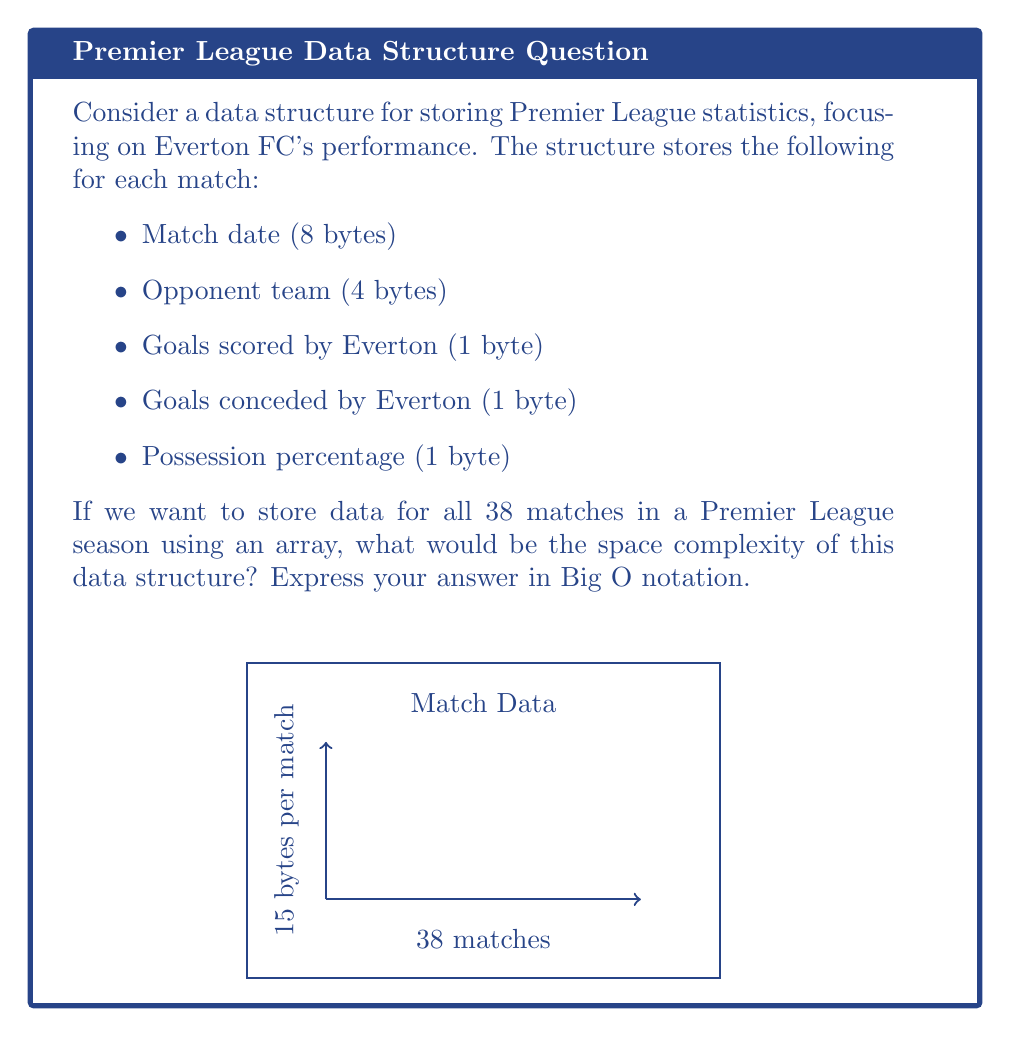Help me with this question. Let's approach this step-by-step:

1) First, we need to calculate the total number of bytes required for each match:
   $8 + 4 + 1 + 1 + 1 = 15$ bytes per match

2) We know there are 38 matches in a Premier League season.

3) Therefore, the total space required is:
   $38 \times 15 = 570$ bytes

4) In Big O notation, we're concerned with how the space requirement grows with respect to the input size. In this case, the input size is the number of matches, which we can call $n$.

5) The space required grows linearly with the number of matches. For each additional match, we need 15 more bytes.

6) This linear growth is represented in Big O notation as $O(n)$.

7) The constant factor (15 in this case) is dropped in Big O notation as we're primarily concerned with the rate of growth, not the exact size.

Therefore, the space complexity of this data structure is $O(n)$, where $n$ is the number of matches.
Answer: $O(n)$ 